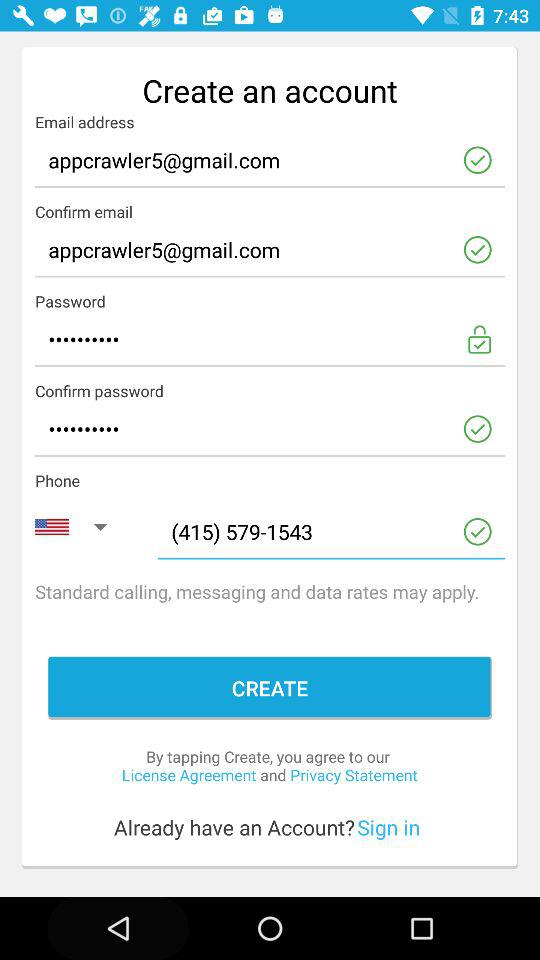Which country codes are available in the drop-down menu?
When the provided information is insufficient, respond with <no answer>. <no answer> 